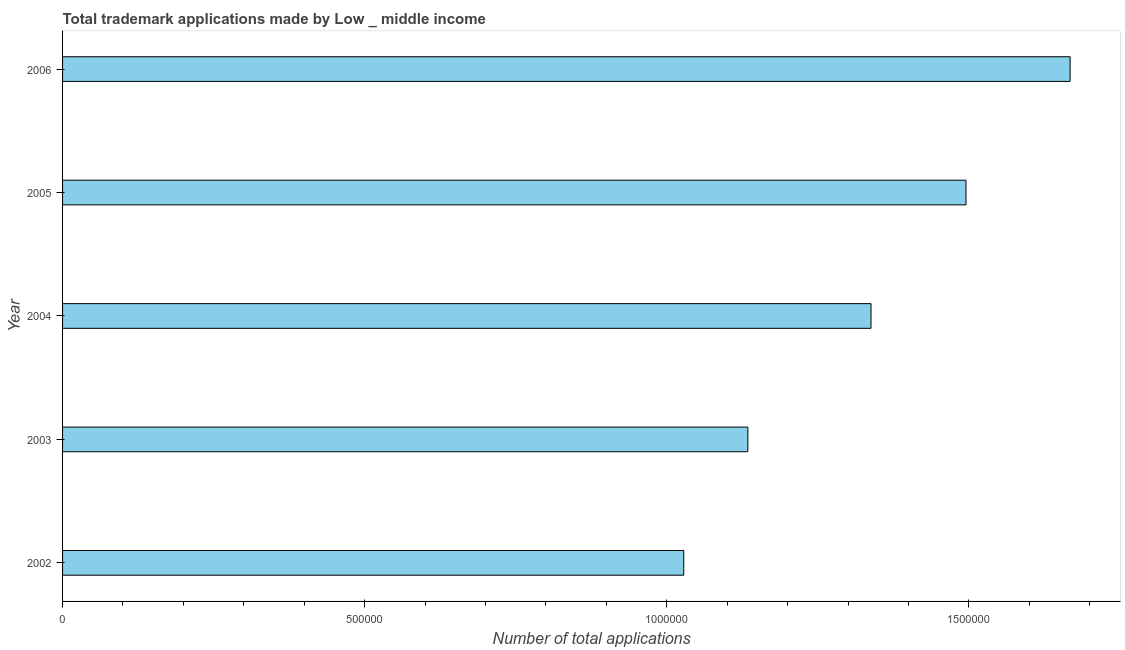Does the graph contain grids?
Offer a very short reply. No. What is the title of the graph?
Offer a terse response. Total trademark applications made by Low _ middle income. What is the label or title of the X-axis?
Keep it short and to the point. Number of total applications. What is the label or title of the Y-axis?
Your answer should be compact. Year. What is the number of trademark applications in 2005?
Offer a terse response. 1.50e+06. Across all years, what is the maximum number of trademark applications?
Keep it short and to the point. 1.67e+06. Across all years, what is the minimum number of trademark applications?
Provide a succinct answer. 1.03e+06. In which year was the number of trademark applications maximum?
Your answer should be very brief. 2006. In which year was the number of trademark applications minimum?
Your answer should be compact. 2002. What is the sum of the number of trademark applications?
Offer a very short reply. 6.66e+06. What is the difference between the number of trademark applications in 2002 and 2005?
Give a very brief answer. -4.67e+05. What is the average number of trademark applications per year?
Keep it short and to the point. 1.33e+06. What is the median number of trademark applications?
Give a very brief answer. 1.34e+06. In how many years, is the number of trademark applications greater than 200000 ?
Provide a succinct answer. 5. Do a majority of the years between 2002 and 2006 (inclusive) have number of trademark applications greater than 100000 ?
Your answer should be compact. Yes. What is the ratio of the number of trademark applications in 2002 to that in 2006?
Provide a short and direct response. 0.62. Is the number of trademark applications in 2002 less than that in 2003?
Give a very brief answer. Yes. What is the difference between the highest and the second highest number of trademark applications?
Offer a very short reply. 1.72e+05. Is the sum of the number of trademark applications in 2003 and 2004 greater than the maximum number of trademark applications across all years?
Offer a terse response. Yes. What is the difference between the highest and the lowest number of trademark applications?
Give a very brief answer. 6.39e+05. Are all the bars in the graph horizontal?
Ensure brevity in your answer.  Yes. What is the difference between two consecutive major ticks on the X-axis?
Offer a terse response. 5.00e+05. What is the Number of total applications in 2002?
Keep it short and to the point. 1.03e+06. What is the Number of total applications in 2003?
Offer a very short reply. 1.13e+06. What is the Number of total applications of 2004?
Make the answer very short. 1.34e+06. What is the Number of total applications in 2005?
Offer a very short reply. 1.50e+06. What is the Number of total applications of 2006?
Offer a terse response. 1.67e+06. What is the difference between the Number of total applications in 2002 and 2003?
Provide a short and direct response. -1.06e+05. What is the difference between the Number of total applications in 2002 and 2004?
Keep it short and to the point. -3.10e+05. What is the difference between the Number of total applications in 2002 and 2005?
Provide a succinct answer. -4.67e+05. What is the difference between the Number of total applications in 2002 and 2006?
Make the answer very short. -6.39e+05. What is the difference between the Number of total applications in 2003 and 2004?
Offer a terse response. -2.04e+05. What is the difference between the Number of total applications in 2003 and 2005?
Your answer should be compact. -3.61e+05. What is the difference between the Number of total applications in 2003 and 2006?
Offer a very short reply. -5.33e+05. What is the difference between the Number of total applications in 2004 and 2005?
Your answer should be compact. -1.57e+05. What is the difference between the Number of total applications in 2004 and 2006?
Ensure brevity in your answer.  -3.30e+05. What is the difference between the Number of total applications in 2005 and 2006?
Your answer should be very brief. -1.72e+05. What is the ratio of the Number of total applications in 2002 to that in 2003?
Your answer should be compact. 0.91. What is the ratio of the Number of total applications in 2002 to that in 2004?
Keep it short and to the point. 0.77. What is the ratio of the Number of total applications in 2002 to that in 2005?
Offer a terse response. 0.69. What is the ratio of the Number of total applications in 2002 to that in 2006?
Keep it short and to the point. 0.62. What is the ratio of the Number of total applications in 2003 to that in 2004?
Ensure brevity in your answer.  0.85. What is the ratio of the Number of total applications in 2003 to that in 2005?
Give a very brief answer. 0.76. What is the ratio of the Number of total applications in 2003 to that in 2006?
Your answer should be very brief. 0.68. What is the ratio of the Number of total applications in 2004 to that in 2005?
Your answer should be very brief. 0.9. What is the ratio of the Number of total applications in 2004 to that in 2006?
Keep it short and to the point. 0.8. What is the ratio of the Number of total applications in 2005 to that in 2006?
Your answer should be very brief. 0.9. 